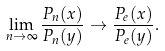<formula> <loc_0><loc_0><loc_500><loc_500>\lim _ { n \rightarrow \infty } \frac { P _ { n } ( x ) } { P _ { n } ( y ) } \rightarrow \frac { P _ { e } ( x ) } { P _ { e } ( y ) } .</formula> 